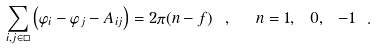Convert formula to latex. <formula><loc_0><loc_0><loc_500><loc_500>\sum _ { i , j \in \Box } \left ( \varphi _ { i } - \varphi _ { j } - A _ { i j } \right ) = 2 \pi ( n - f ) \ , \ \ n = 1 , \ 0 , \ - 1 \ .</formula> 